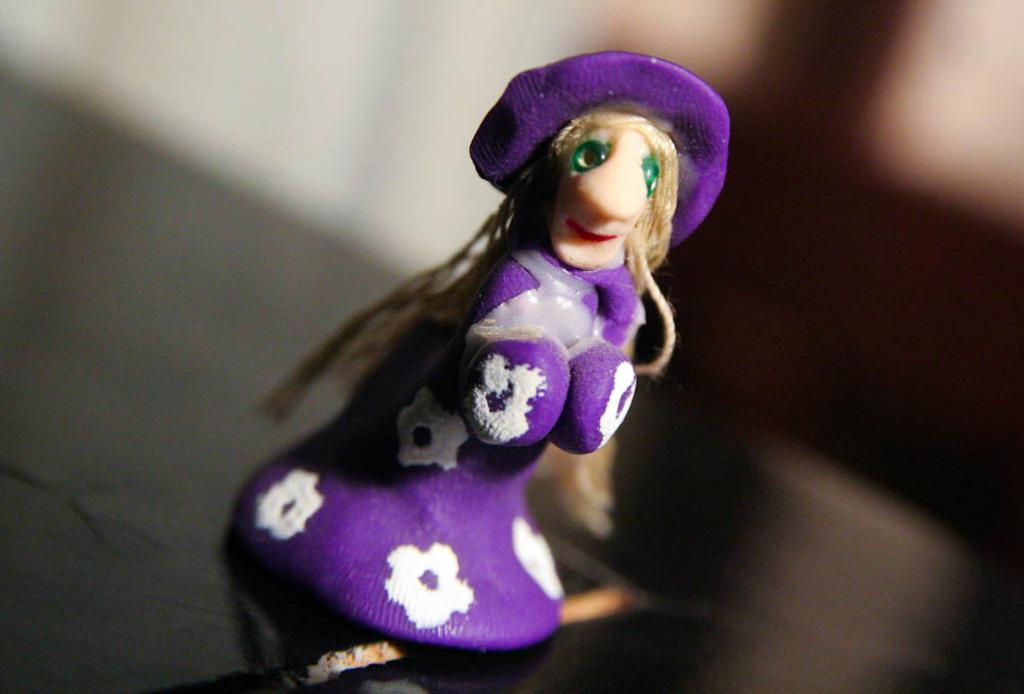What object can be seen in the image? There is a toy in the image. What color is the toy? The toy is violet in color. Can you describe the background of the image? The background of the image is blurred. What type of legal advice can be obtained from the toy in the image? There is no lawyer or legal advice present in the image; it features a violet-colored toy with a blurred background. 